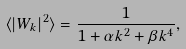Convert formula to latex. <formula><loc_0><loc_0><loc_500><loc_500>\langle | W _ { k } | ^ { 2 } \rangle = \frac { 1 } { 1 + \alpha k ^ { 2 } + \beta k ^ { 4 } } ,</formula> 